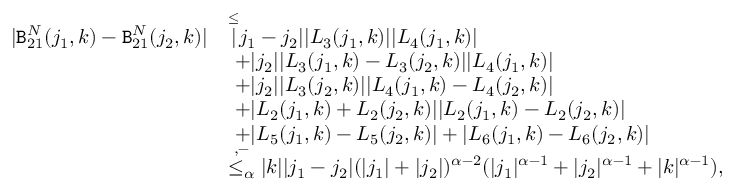<formula> <loc_0><loc_0><loc_500><loc_500>\begin{array} { r l } { | B _ { 2 1 } ^ { N } ( j _ { 1 } , k ) - B _ { 2 1 } ^ { N } ( j _ { 2 } , k ) | } & { \overset { \leq } { | } j _ { 1 } - j _ { 2 } | | L _ { 3 } ( j _ { 1 } , k ) | | L _ { 4 } ( j _ { 1 } , k ) | } \\ & { \ + | j _ { 2 } | | L _ { 3 } ( j _ { 1 } , k ) - L _ { 3 } ( j _ { 2 } , k ) | | L _ { 4 } ( j _ { 1 } , k ) | } \\ & { \ + | j _ { 2 } | | L _ { 3 } ( j _ { 2 } , k ) | | L _ { 4 } ( j _ { 1 } , k ) - L _ { 4 } ( j _ { 2 } , k ) | } \\ & { \ + | L _ { 2 } ( j _ { 1 } , k ) + L _ { 2 } ( j _ { 2 } , k ) | | L _ { 2 } ( j _ { 1 } , k ) - L _ { 2 } ( j _ { 2 } , k ) | } \\ & { \ + | L _ { 5 } ( j _ { 1 } , k ) - L _ { 5 } ( j _ { 2 } , k ) | + | L _ { 6 } ( j _ { 1 } , k ) - L _ { 6 } ( j _ { 2 } , k ) | } \\ & { \overset { , - } { \leq _ { \alpha } } | k | | j _ { 1 } - j _ { 2 } | ( | j _ { 1 } | + | j _ { 2 } | ) ^ { \alpha - 2 } ( | j _ { 1 } | ^ { \alpha - 1 } + | j _ { 2 } | ^ { \alpha - 1 } + | k | ^ { \alpha - 1 } ) , } \end{array}</formula> 